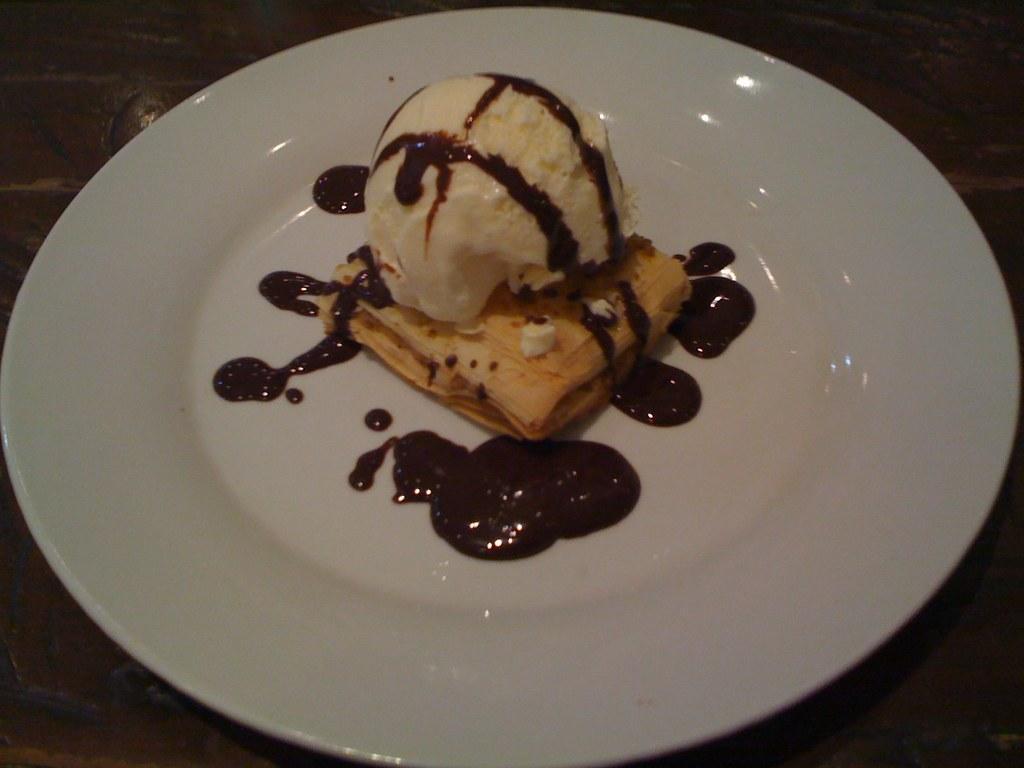Could you give a brief overview of what you see in this image? In this picture we can see food in the plate and we can see dark background. 